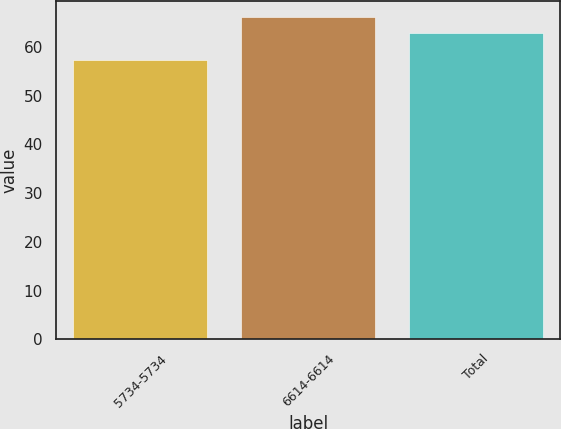<chart> <loc_0><loc_0><loc_500><loc_500><bar_chart><fcel>5734-5734<fcel>6614-6614<fcel>Total<nl><fcel>57.34<fcel>66.14<fcel>62.86<nl></chart> 